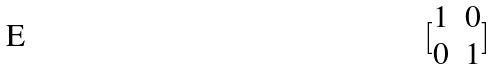<formula> <loc_0><loc_0><loc_500><loc_500>[ \begin{matrix} 1 & 0 \\ 0 & 1 \end{matrix} ]</formula> 